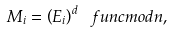Convert formula to latex. <formula><loc_0><loc_0><loc_500><loc_500>M _ { i } = \left ( E _ { i } \right ) ^ { d } \ f u n c { m o d } n ,</formula> 